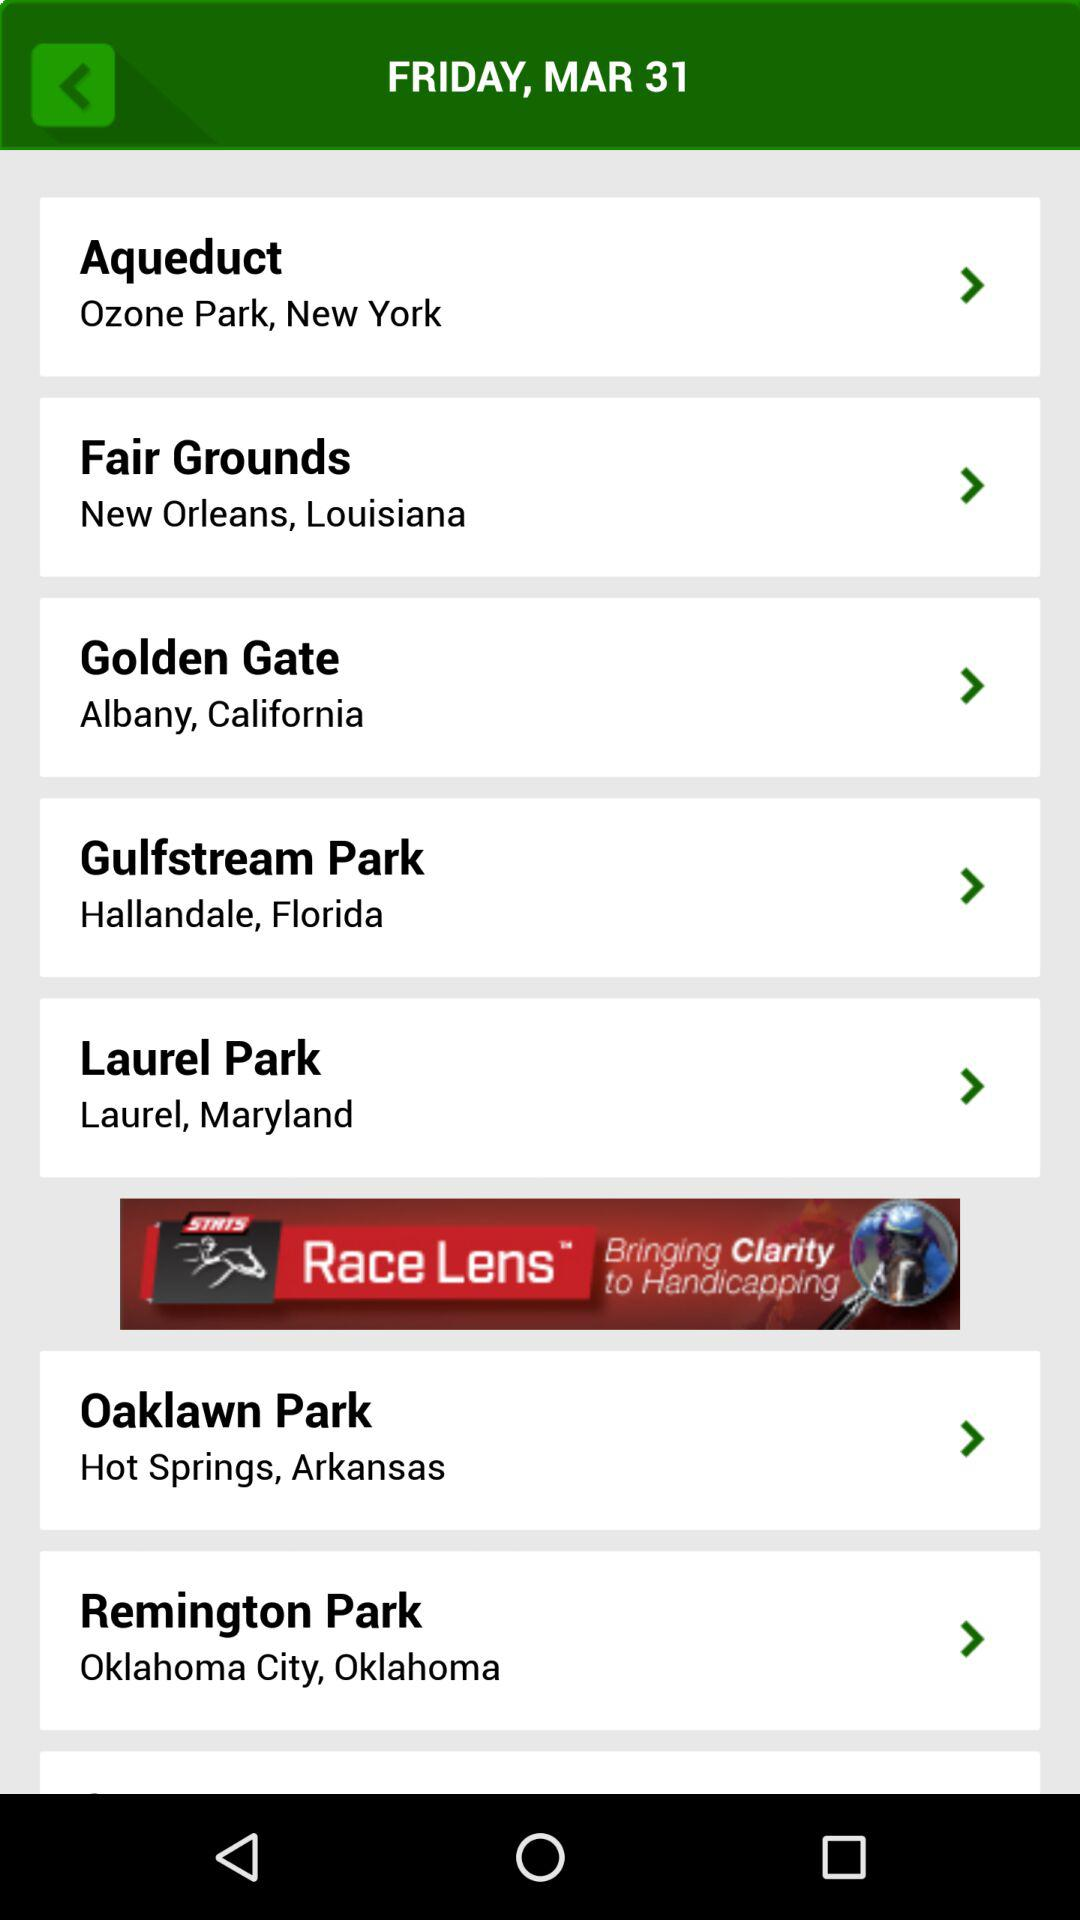What is the date shown on the screen? The date shown on the screen is Friday, March 31. 